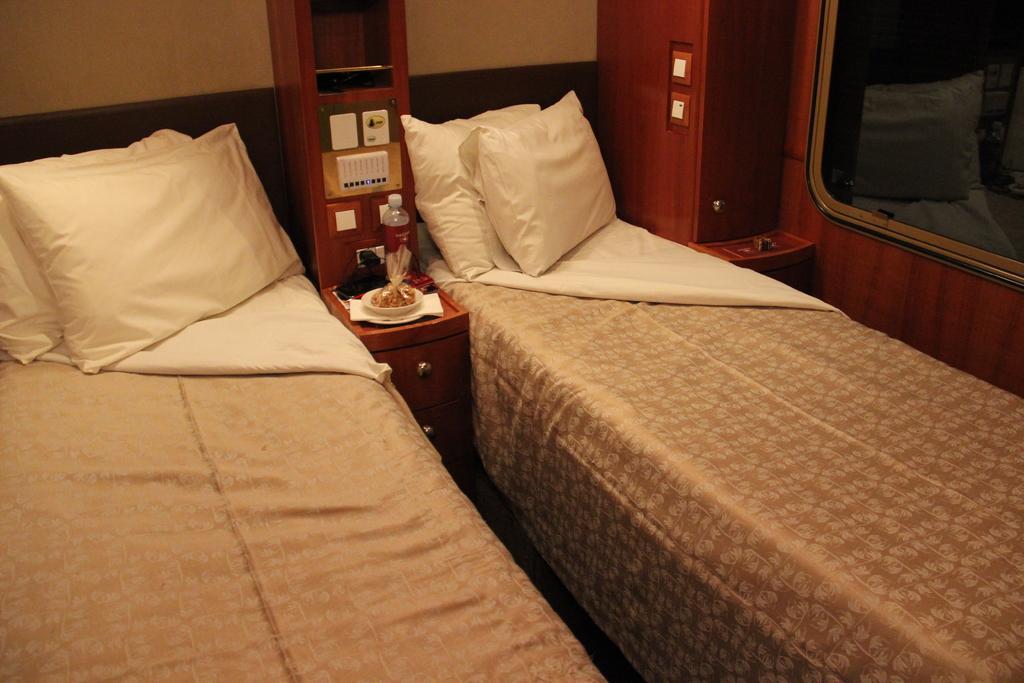Describe this image in one or two sentences. In this picture we can see beds. On the beds we can see pillow and cloth. On the background we can see wall. This is glass window. This is cupboard. On cupboard we can see bottle,food,bowl,paper. This is switch. 